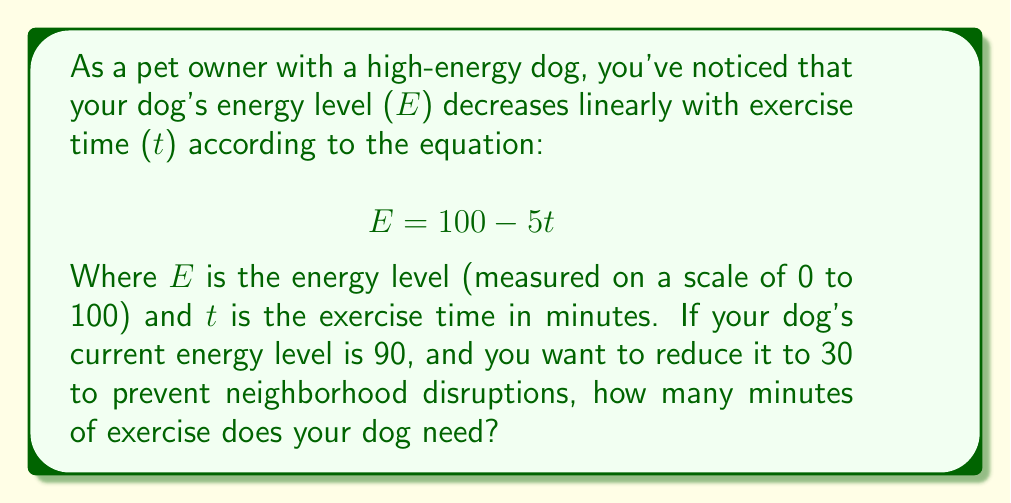Could you help me with this problem? To solve this problem, we need to use the given linear equation and find the value of t when E = 30. Let's follow these steps:

1) We start with the equation: $$E = 100 - 5t$$

2) We want to find t when E = 30, so we substitute E with 30:
   $$30 = 100 - 5t$$

3) Now we solve for t:
   Subtract 100 from both sides:
   $$-70 = -5t$$

4) Divide both sides by -5:
   $$14 = t$$

5) Therefore, t = 14 minutes of exercise are needed.

To verify:
If we plug t = 14 back into the original equation:
$$E = 100 - 5(14) = 100 - 70 = 30$$

This confirms that 14 minutes of exercise will reduce the dog's energy level to 30.
Answer: 14 minutes 